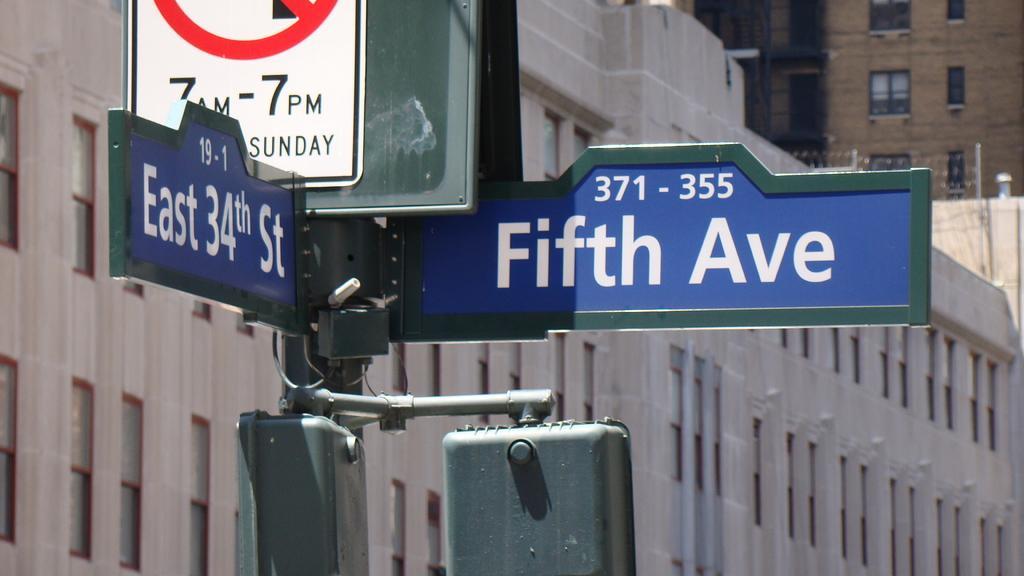Describe this image in one or two sentences. In this picture I can see boards attached to a pole, and in the background there are buildings. 